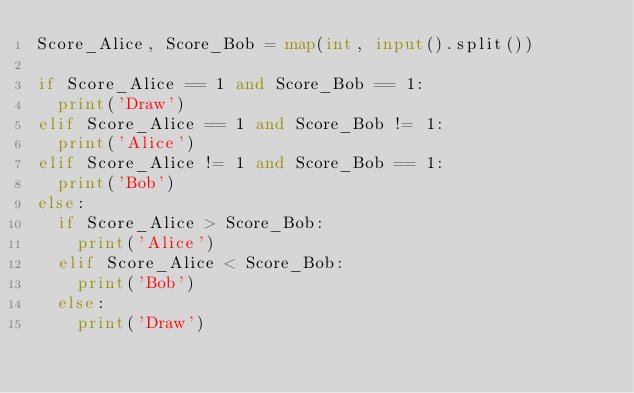<code> <loc_0><loc_0><loc_500><loc_500><_Python_>Score_Alice, Score_Bob = map(int, input().split())

if Score_Alice == 1 and Score_Bob == 1:
  print('Draw')
elif Score_Alice == 1 and Score_Bob != 1:
  print('Alice')
elif Score_Alice != 1 and Score_Bob == 1:
  print('Bob')
else:
  if Score_Alice > Score_Bob:
    print('Alice')
  elif Score_Alice < Score_Bob:
    print('Bob')
  else:
    print('Draw')</code> 